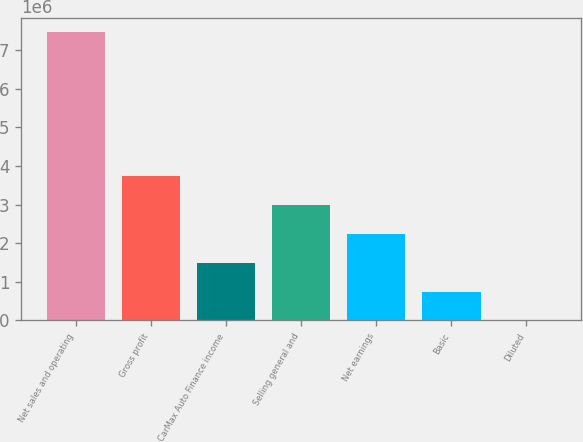<chart> <loc_0><loc_0><loc_500><loc_500><bar_chart><fcel>Net sales and operating<fcel>Gross profit<fcel>CarMax Auto Finance income<fcel>Selling general and<fcel>Net earnings<fcel>Basic<fcel>Diluted<nl><fcel>7.46566e+06<fcel>3.73283e+06<fcel>1.49313e+06<fcel>2.98626e+06<fcel>2.2397e+06<fcel>746566<fcel>0.92<nl></chart> 